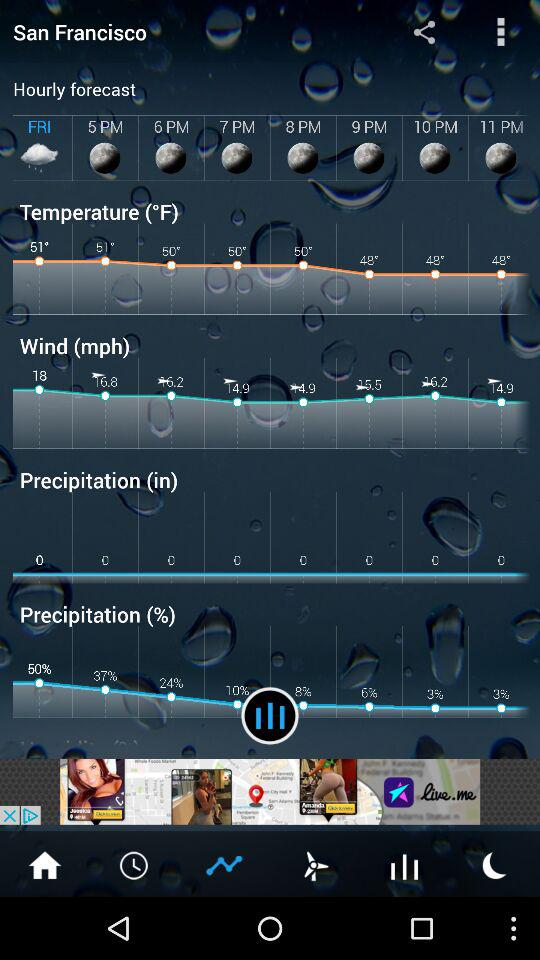How is the weather on Friday? The weather on Friday is rainy. 